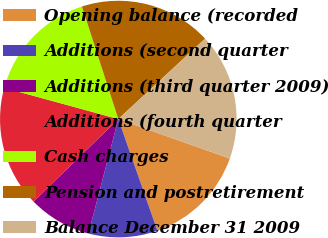Convert chart. <chart><loc_0><loc_0><loc_500><loc_500><pie_chart><fcel>Opening balance (recorded<fcel>Additions (second quarter<fcel>Additions (third quarter 2009)<fcel>Additions (fourth quarter<fcel>Cash charges<fcel>Pension and postretirement<fcel>Balance December 31 2009<nl><fcel>14.23%<fcel>9.42%<fcel>8.65%<fcel>16.54%<fcel>15.77%<fcel>18.08%<fcel>17.31%<nl></chart> 